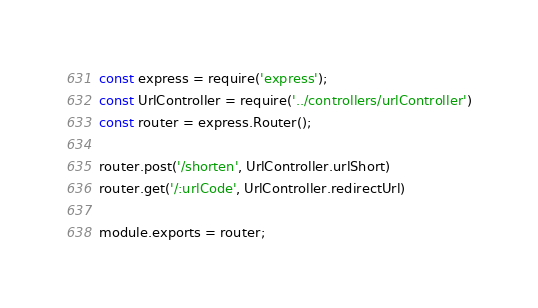Convert code to text. <code><loc_0><loc_0><loc_500><loc_500><_JavaScript_>const express = require('express');
const UrlController = require('../controllers/urlController')
const router = express.Router();

router.post('/shorten', UrlController.urlShort)
router.get('/:urlCode', UrlController.redirectUrl)

module.exports = router;</code> 